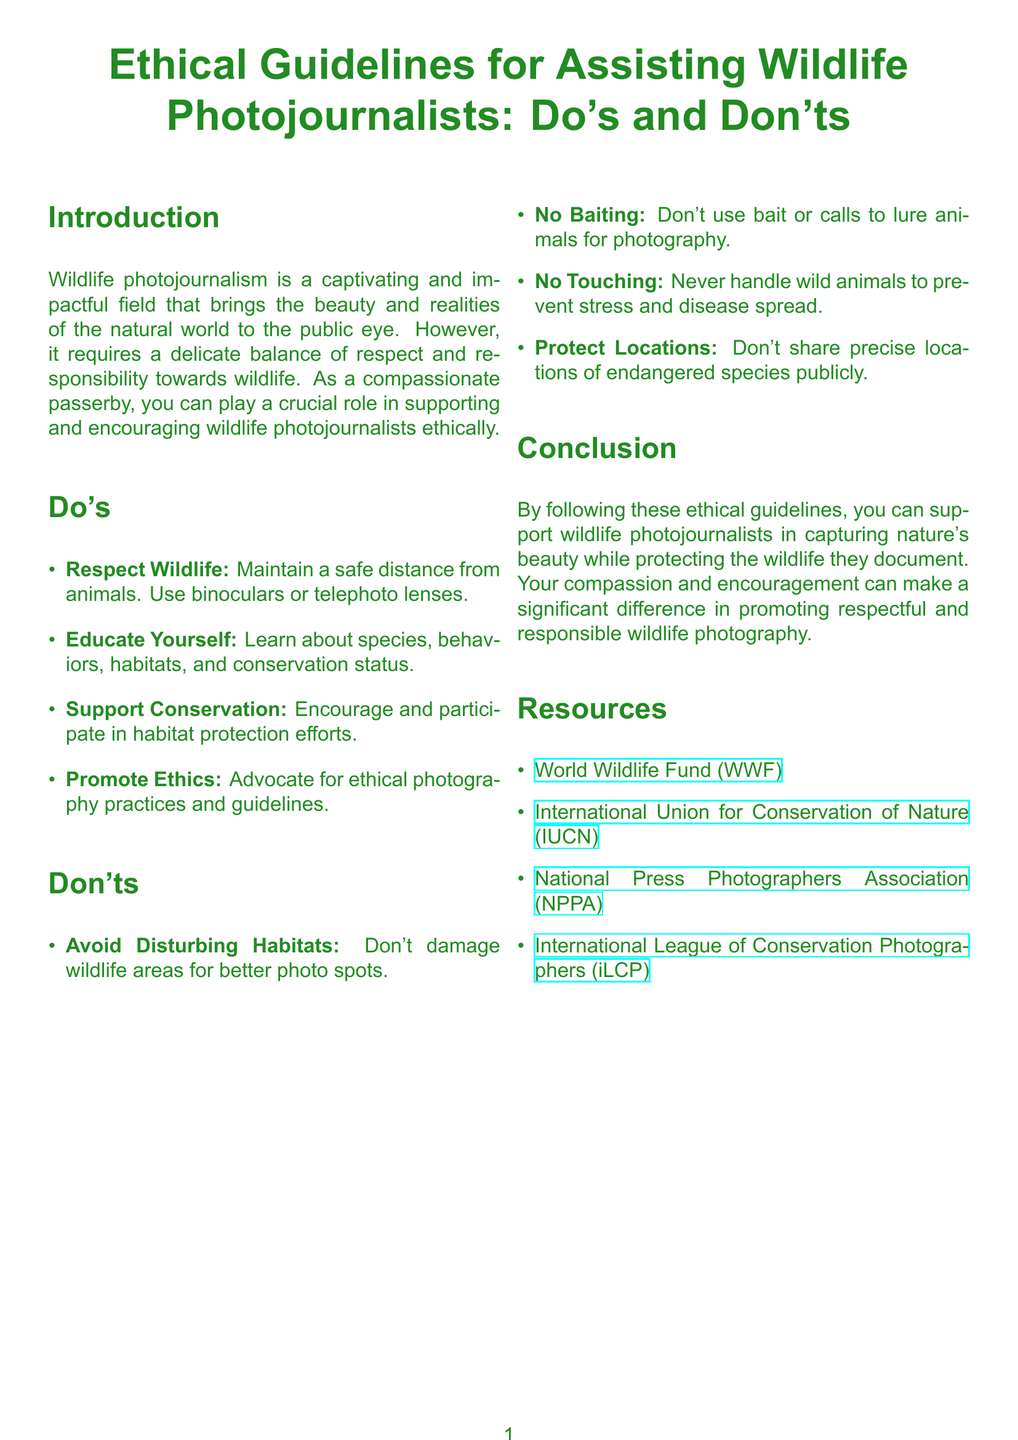What is the title of the document? The title of the document is located at the beginning and clearly states the subject matter.
Answer: Ethical Guidelines for Assisting Wildlife Photojournalists: Do's and Don'ts How many sections are there in the Do's list? The Do's list consists of four distinct items focused on ethical practices.
Answer: 4 What should you use to maintain a safe distance from animals? The document suggests specific tools to ensure safety while observing wildlife.
Answer: Binoculars or telephoto lenses What is one of the Don'ts related to wildlife locations? One of the Don'ts emphasizes the responsibility to safeguard sensitive wildlife spots.
Answer: Don't share precise locations of endangered species publicly Which organization focuses on wildlife conservation? The document lists multiple resources, one of which is a prominent conservation organization.
Answer: World Wildlife Fund (WWF) How many items are listed in the Don'ts section? The Don'ts section contains essential guidelines, totaling a specific number of practices to avoid.
Answer: 4 What is the main goal of the document? The document aims to inform and guide on ethical practices in wildlife photojournalism.
Answer: Support wildlife photojournalists Which guideline encourages education about wildlife? The document emphasizes the importance of knowledge as a foundation for ethical engagement.
Answer: Educate Yourself 